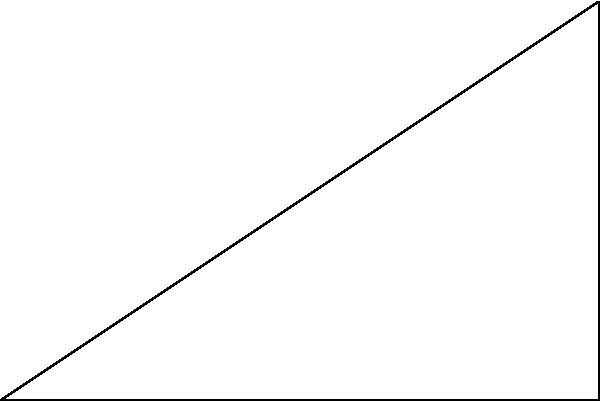As a lupus blogger concerned with UV protection, you're researching the angle of elevation to the sun. If an observer stands 6 meters away from a point directly below the sun, and the sun appears to be 4 meters above the ground from that point, what is the angle of elevation ($\theta$) to the sun? Round your answer to the nearest degree. To find the angle of elevation to the sun, we need to use trigonometry. Let's approach this step-by-step:

1) We have a right triangle with the following measurements:
   - Adjacent side (ground distance) = 6 meters
   - Opposite side (height) = 4 meters
   - We need to find the angle $\theta$

2) In this case, we can use the tangent function, which is defined as:

   $\tan(\theta) = \frac{\text{opposite}}{\text{adjacent}}$

3) Plugging in our values:

   $\tan(\theta) = \frac{4}{6} = \frac{2}{3}$

4) To find $\theta$, we need to use the inverse tangent (arctan) function:

   $\theta = \arctan(\frac{2}{3})$

5) Using a calculator or computer:

   $\theta \approx 33.69$ degrees

6) Rounding to the nearest degree:

   $\theta \approx 34$ degrees

This angle of elevation is important for lupus patients to understand when the sun's rays are most direct and potentially harmful, helping them plan their outdoor activities and UV protection strategies accordingly.
Answer: 34° 